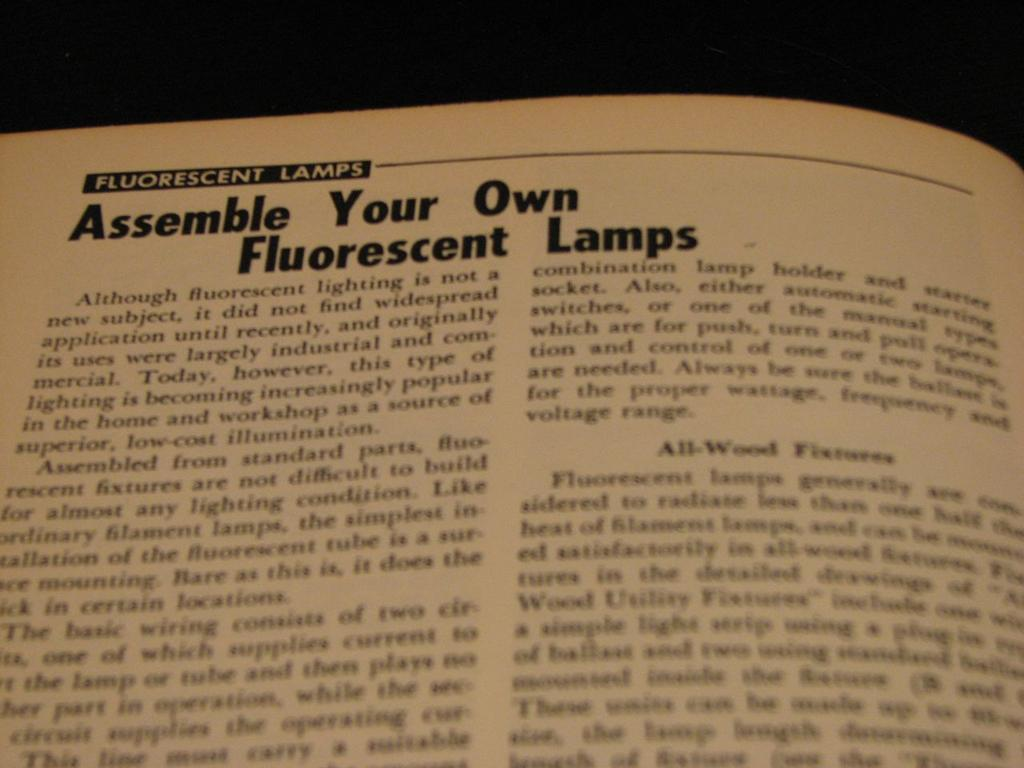<image>
Summarize the visual content of the image. a page that says 'fluorescent lamps' at the top of it 